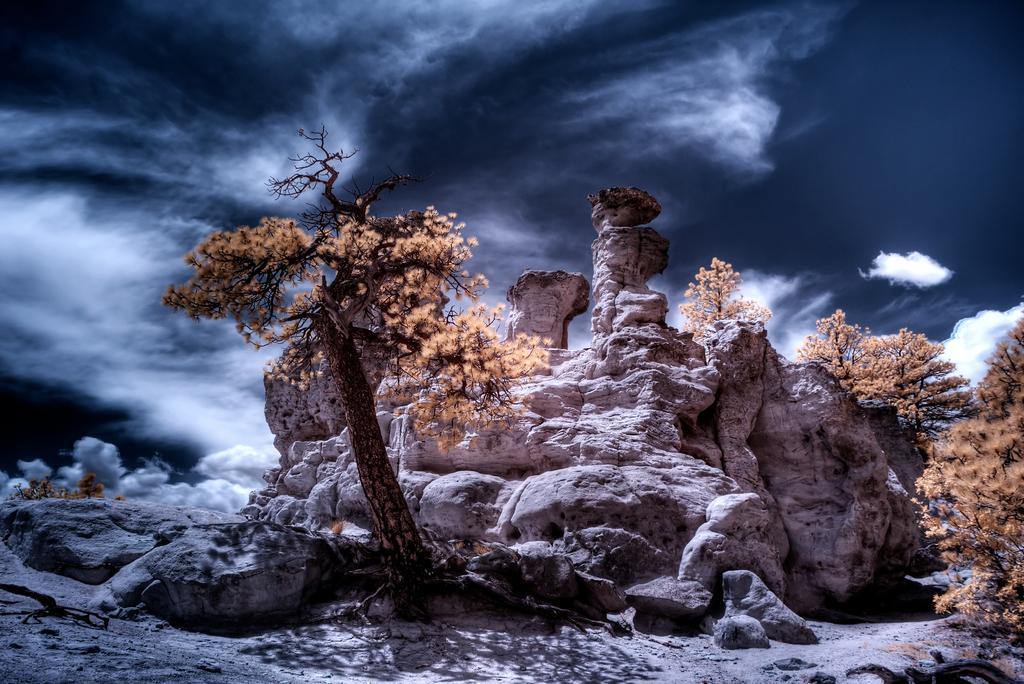Could you give a brief overview of what you see in this image? In this image I can see few trees in the front. In the background I can see clouds and the sky. 